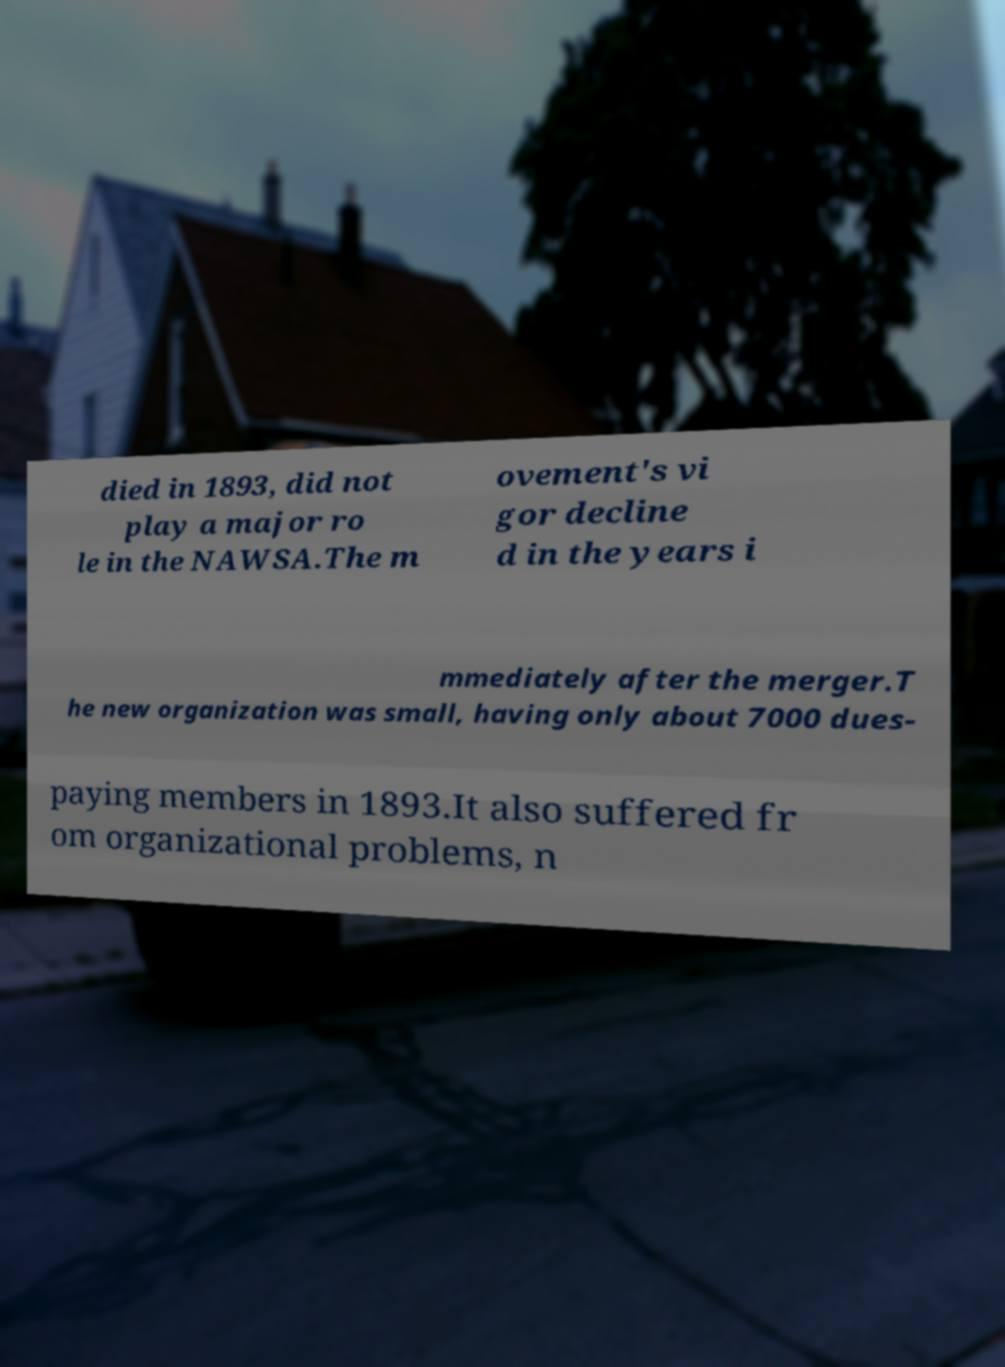For documentation purposes, I need the text within this image transcribed. Could you provide that? died in 1893, did not play a major ro le in the NAWSA.The m ovement's vi gor decline d in the years i mmediately after the merger.T he new organization was small, having only about 7000 dues- paying members in 1893.It also suffered fr om organizational problems, n 